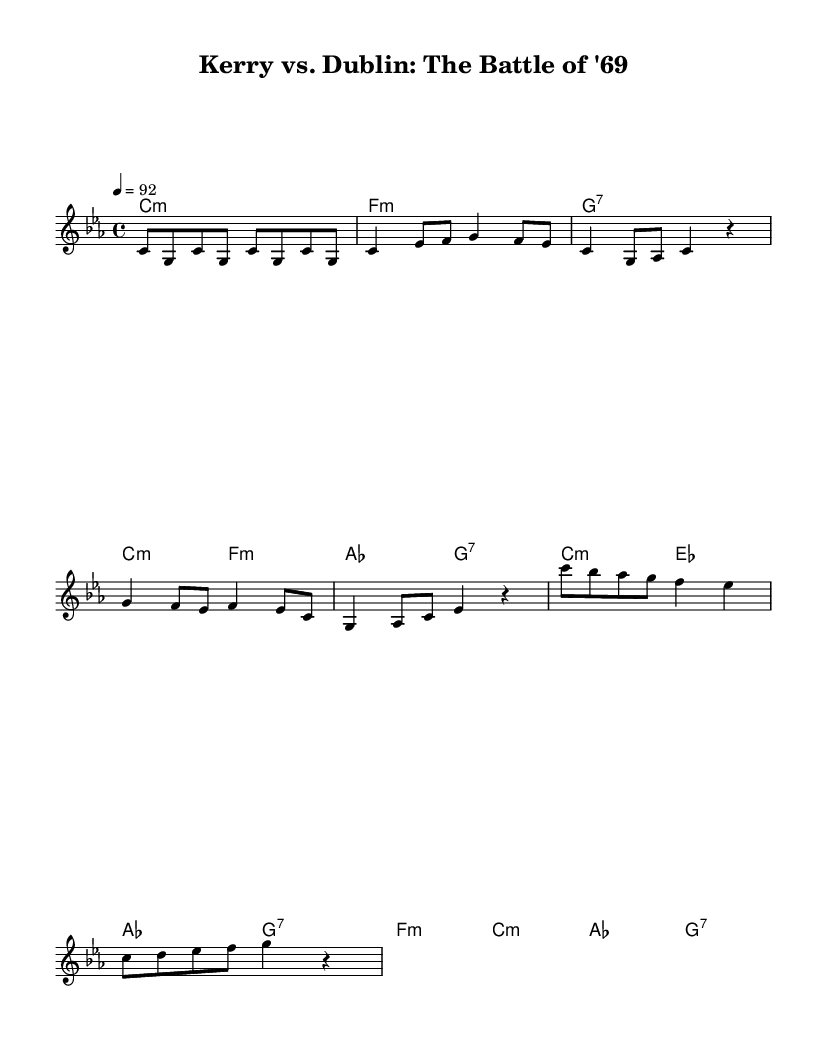What is the key signature of this music? The key signature is C minor, which has three flats (B, E, and A). This can be identified by looking at the key signature placed at the beginning of the staff.
Answer: C minor What is the time signature of the piece? The time signature is 4/4, which indicates that there are four beats in a measure and the quarter note gets the beat. This is visible in the notation at the beginning of the staff.
Answer: 4/4 What is the tempo marking for this music? The tempo marking is 92, indicating the beats per minute. This is noted at the beginning after the time signature.
Answer: 92 How many measures are there in the melody section? Counting the measures in the melody after analyzing the notes, there are a total of 8 measures. Each measure is separated by a vertical line.
Answer: 8 What chord follows the intro section of the music? After the intro section, the verse begins with a C minor chord. This can be determined by analyzing the chord progression indicated in the harmonies.
Answer: C minor What style of music does this piece represent? This piece represents Hip Hop because its structure emphasizes rhythm and storytelling typical of the genre, alongside the cultural context of Irish sports rivalries. This is reflected in both the musical style and thematic elements.
Answer: Hip Hop 